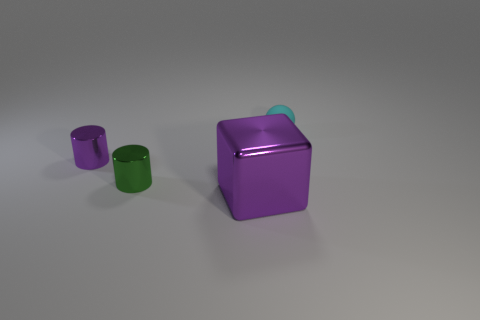The big shiny block is what color?
Make the answer very short. Purple. Is there a tiny green object?
Offer a very short reply. Yes. There is a large metallic thing; are there any tiny shiny cylinders on the right side of it?
Offer a terse response. No. What material is the other tiny thing that is the same shape as the small purple object?
Provide a succinct answer. Metal. Are there any other things that have the same material as the tiny purple cylinder?
Provide a short and direct response. Yes. How many other things are the same shape as the small purple metallic object?
Make the answer very short. 1. What number of tiny things are in front of the tiny matte thing behind the purple object left of the block?
Ensure brevity in your answer.  2. How many other things are the same shape as the tiny green object?
Offer a terse response. 1. There is a thing that is to the right of the large purple thing; does it have the same color as the metal cube?
Ensure brevity in your answer.  No. There is a metallic thing left of the tiny cylinder to the right of the purple shiny object that is on the left side of the large purple metallic object; what shape is it?
Ensure brevity in your answer.  Cylinder. 